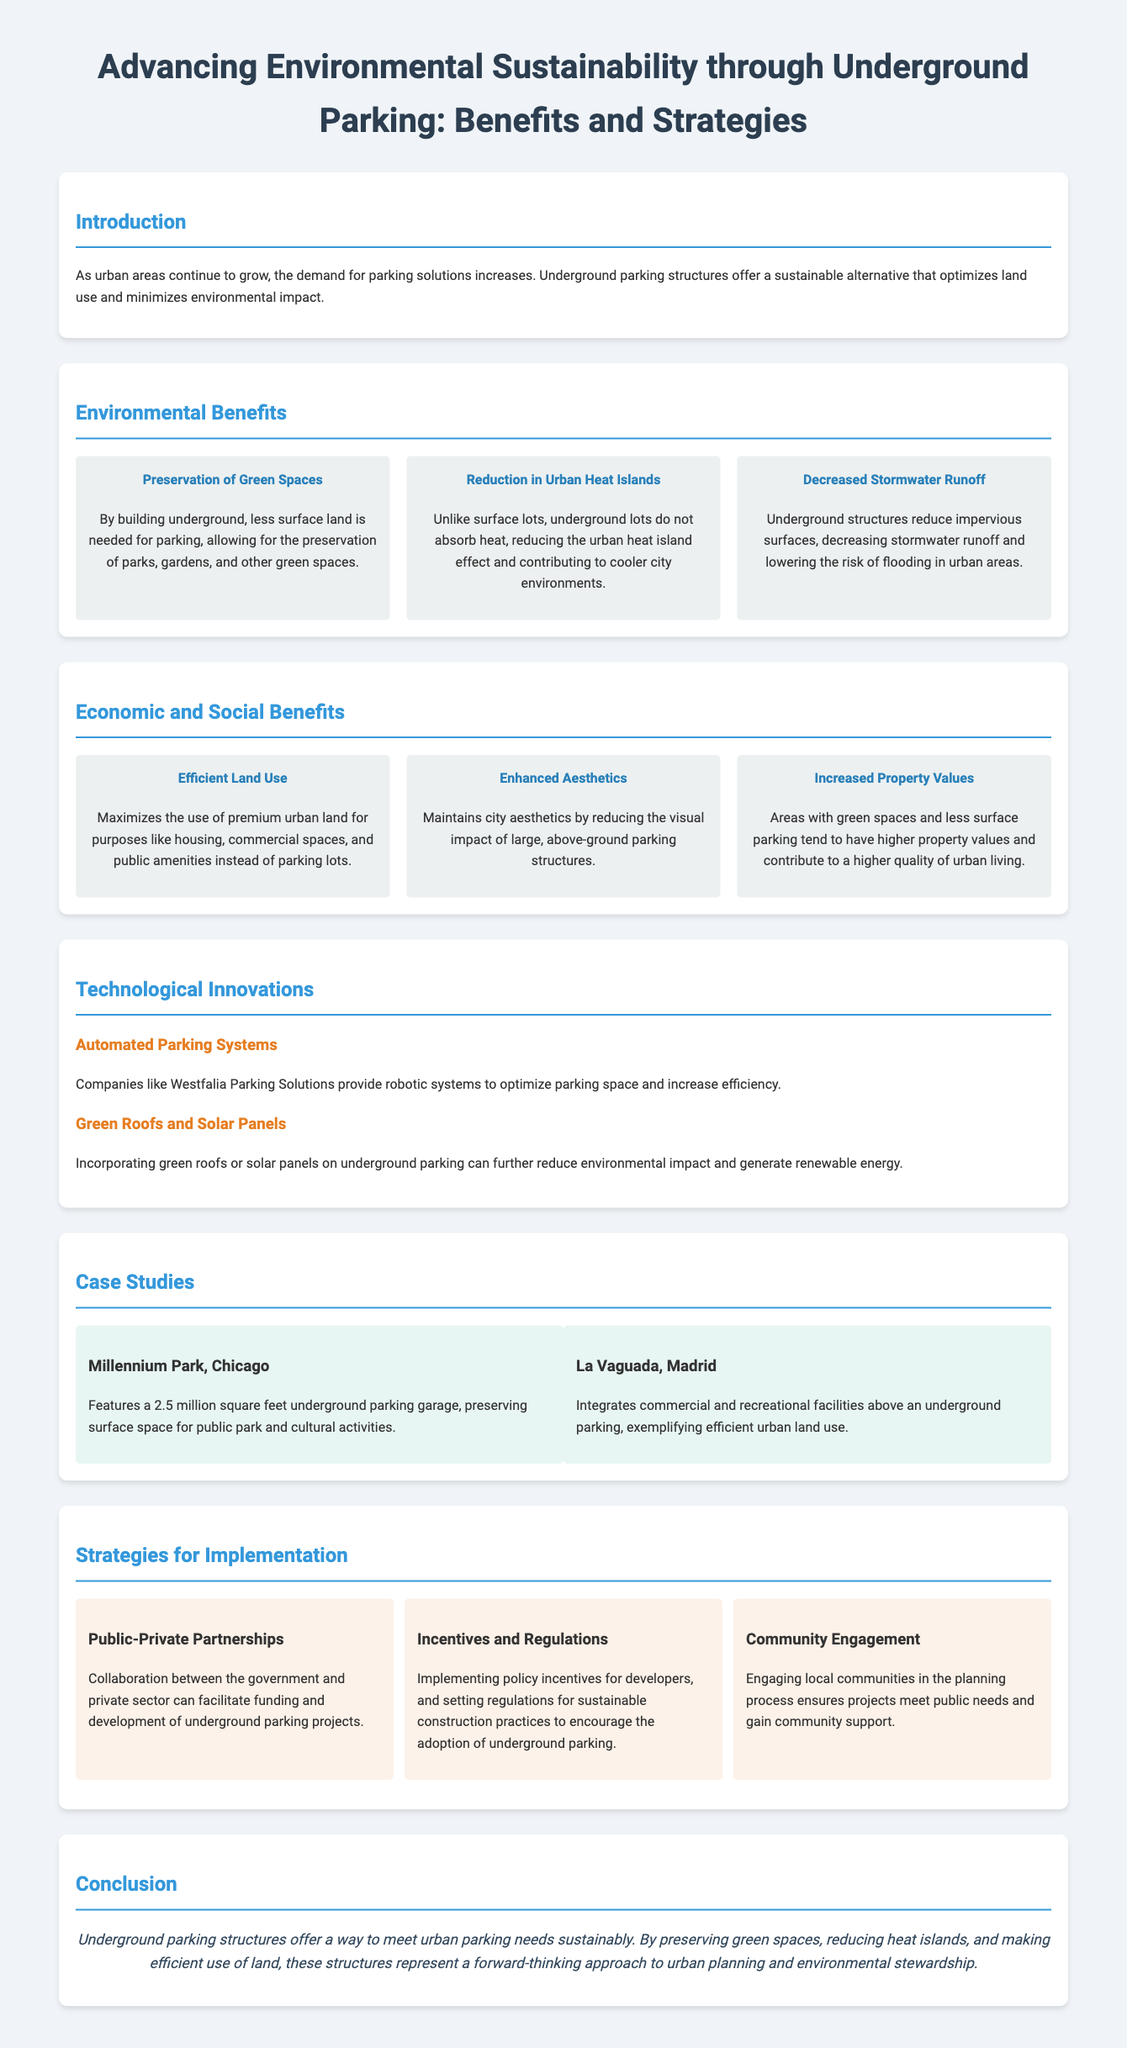What are the environmental benefits of underground parking? The document lists the environmental benefits such as preservation of green spaces, reduction in urban heat islands, and decreased stormwater runoff.
Answer: Preservation of green spaces, reduction in urban heat islands, decreased stormwater runoff What is one technological innovation mentioned in the document? The document highlights automated parking systems and the incorporation of green roofs or solar panels as technological innovations.
Answer: Automated parking systems How many case studies are provided? The document presents two case studies: Millennium Park in Chicago and La Vaguada in Madrid.
Answer: Two What is the conclusion of the infographic? The conclusion emphasizes that underground parking structures meet urban parking needs sustainably and preserve green spaces.
Answer: Sustainable urban parking What strategy involves collaboration between sectors? The strategy that involves collaboration is public-private partnerships, as noted in the strategies for implementation.
Answer: Public-private partnerships 